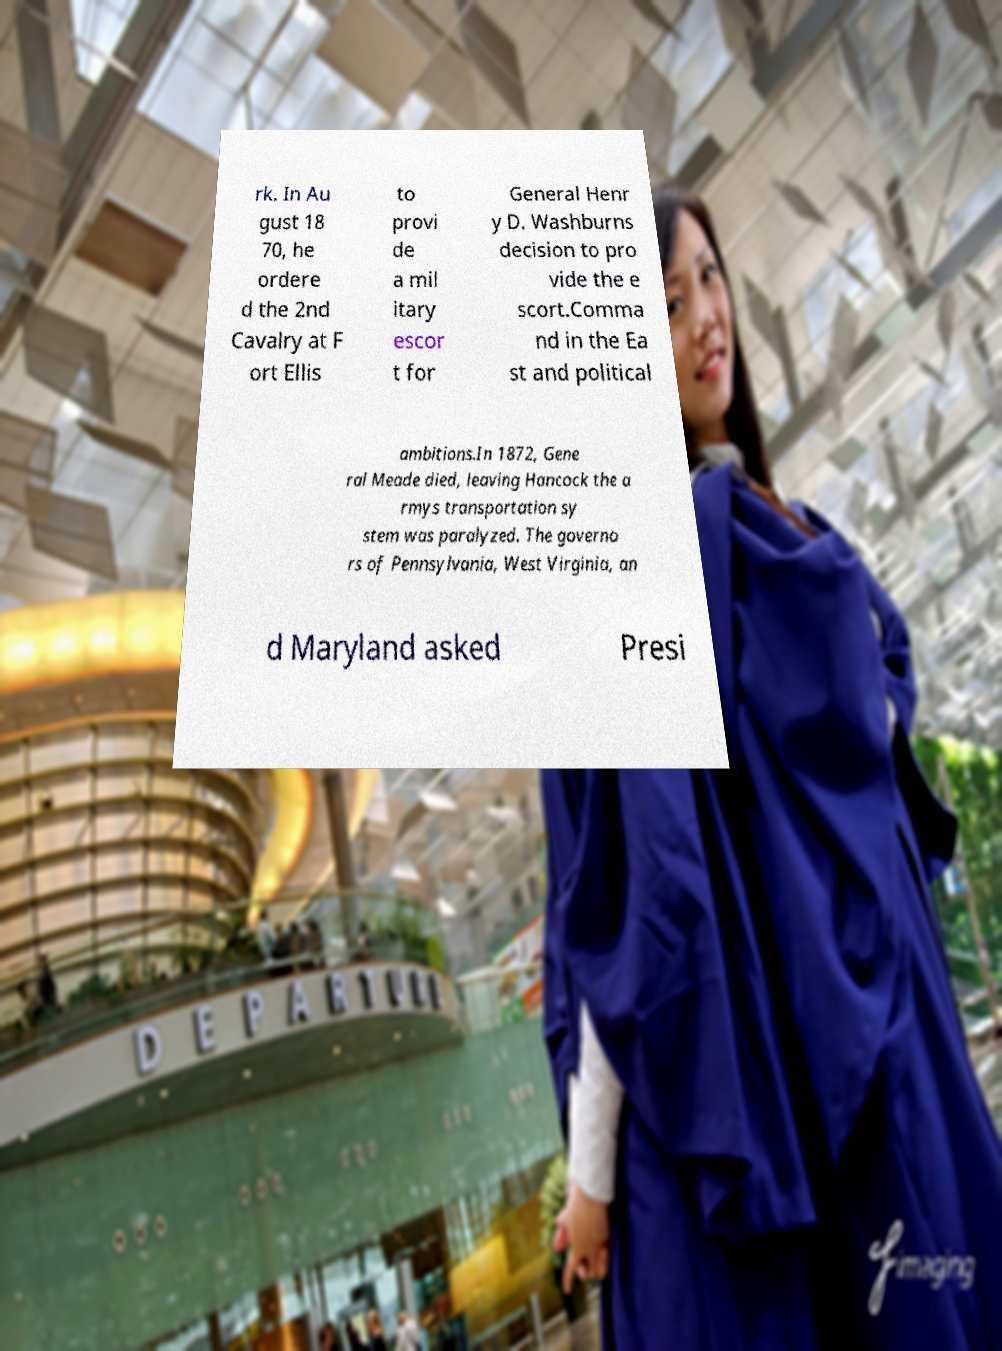Please identify and transcribe the text found in this image. rk. In Au gust 18 70, he ordere d the 2nd Cavalry at F ort Ellis to provi de a mil itary escor t for General Henr y D. Washburns decision to pro vide the e scort.Comma nd in the Ea st and political ambitions.In 1872, Gene ral Meade died, leaving Hancock the a rmys transportation sy stem was paralyzed. The governo rs of Pennsylvania, West Virginia, an d Maryland asked Presi 